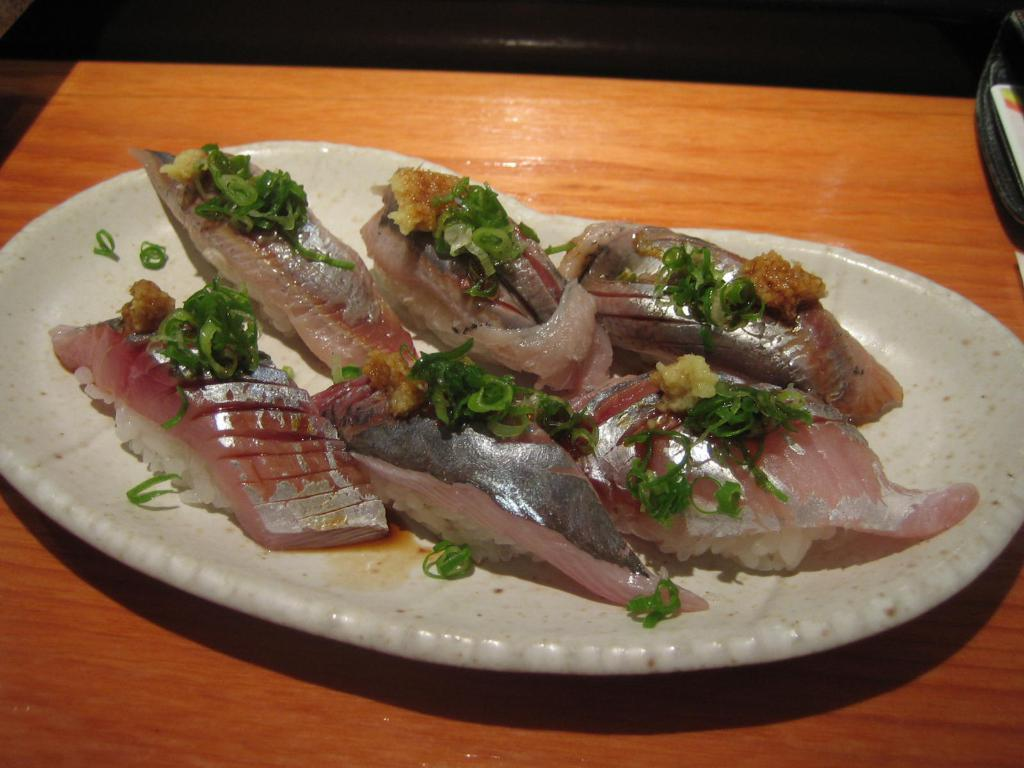What is on the plate that is visible in the image? There is food placed on a plate in the image. Where is the plate located in the image? The plate is on a surface in the image. What can be seen in the background of the image? There is a card in a box in the background of the image. What type of bean is resting on the plate in the image? There is no bean present on the plate in the image. 